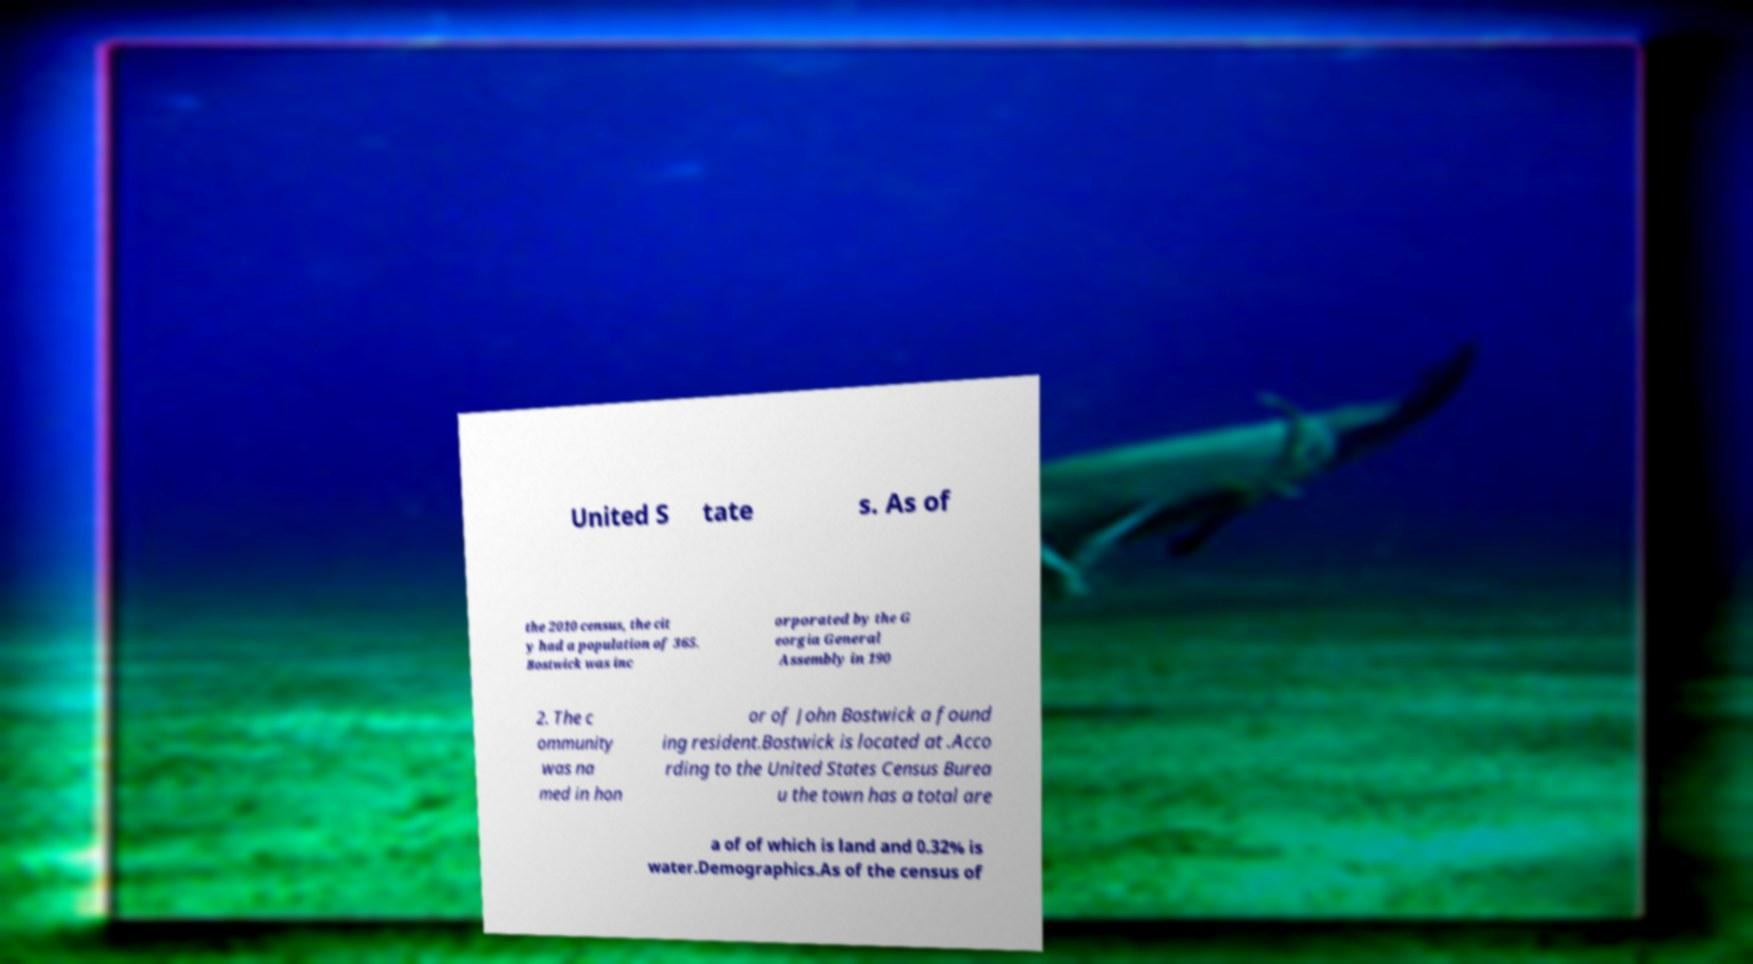Could you assist in decoding the text presented in this image and type it out clearly? United S tate s. As of the 2010 census, the cit y had a population of 365. Bostwick was inc orporated by the G eorgia General Assembly in 190 2. The c ommunity was na med in hon or of John Bostwick a found ing resident.Bostwick is located at .Acco rding to the United States Census Burea u the town has a total are a of of which is land and 0.32% is water.Demographics.As of the census of 